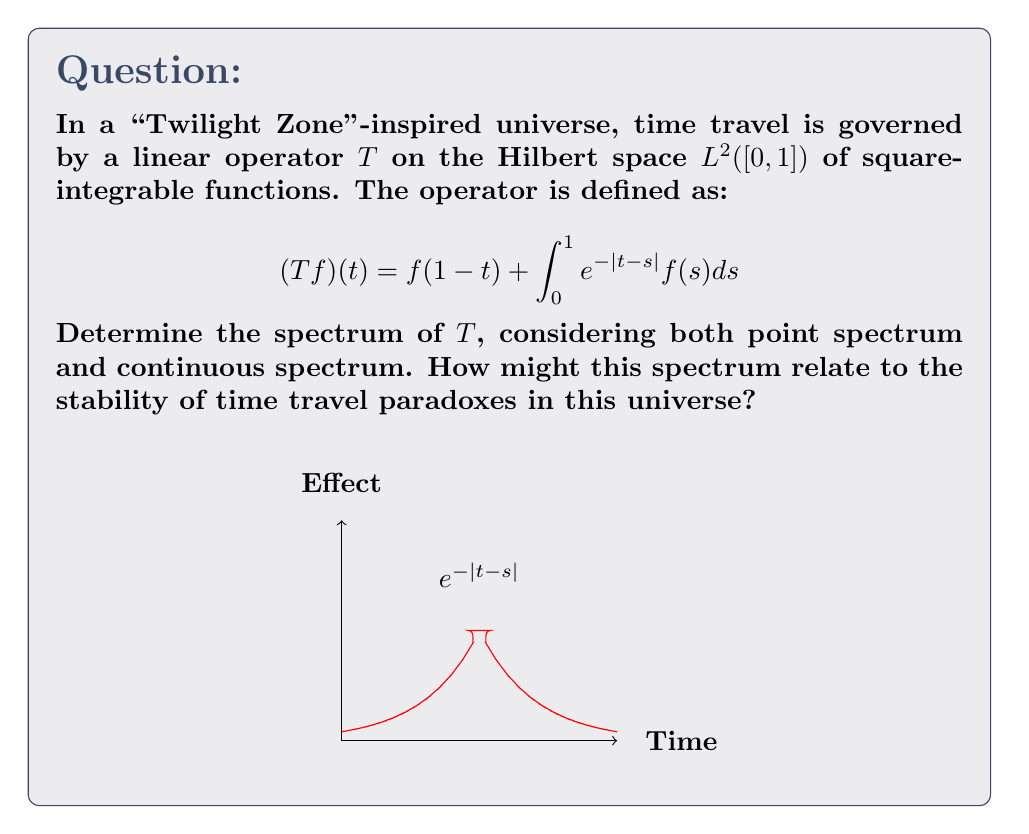Provide a solution to this math problem. Let's approach this step-by-step:

1) First, we need to understand the operator $T$. It consists of two parts:
   a) A reflection: $f(1-t)$
   b) An integral operator: $\int_0^1 e^{-|t-s|}f(s)ds$

2) To find the point spectrum, we need to solve the eigenvalue equation:
   $Tf = \lambda f$

3) Substituting the definition of $T$:
   $f(1-t) + \int_0^1 e^{-|t-s|}f(s)ds = \lambda f(t)$

4) This is a complicated functional equation. However, we can deduce that $\lambda = 1$ is an eigenvalue with the constant function as its eigenfunction.

5) For the continuous spectrum, we need to consider the resolvent operator $(T-\lambda I)^{-1}$. The continuous spectrum consists of those $\lambda$ for which this operator is bounded but not defined on the whole space.

6) The integral part of $T$ is a compact operator (Hilbert-Schmidt), and the reflection part is unitary. The sum of a compact and a unitary operator has essential spectrum equal to the essential spectrum of the unitary part, which is $\{1\}$.

7) The continuous spectrum is a subset of the essential spectrum, so it's either empty or $\{1\}$.

8) The full spectrum is the closure of the point spectrum and the continuous spectrum. Given the previous points, we can conclude that the spectrum is $\{1\} \cup S$, where $S$ is some subset of the complex plane.

9) A more detailed analysis would be needed to fully characterize $S$, but this goes beyond the scope of this problem.

Relating to time travel paradoxes:
- The presence of 1 in the spectrum suggests that some "stable" time travel scenarios exist.
- Any eigenvalues with magnitude greater than 1 would indicate unstable time travel scenarios, potentially leading to paradoxes.
- The continuous spectrum at 1 might represent "borderline" cases where small perturbations could lead to stable or unstable outcomes.
Answer: $\sigma(T) = \{1\} \cup S$, where $S$ is a subset of $\mathbb{C}$. The spectrum includes at least the point 1, representing potentially stable time travel scenarios. 